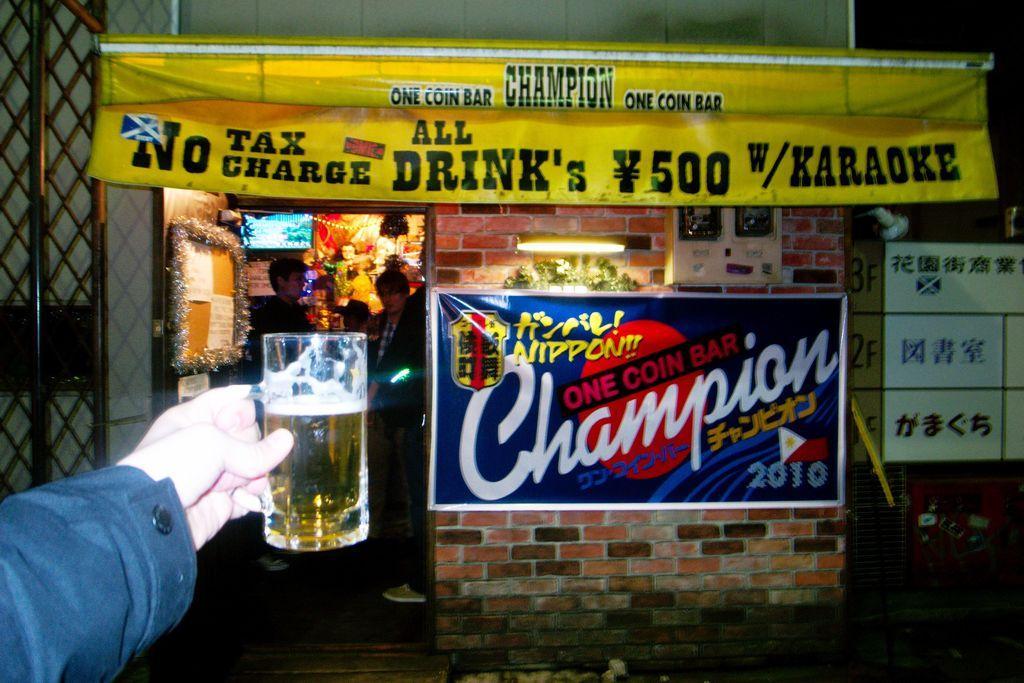Can you describe this image briefly? In this image I can see a person hand and holding glass. Back I can see store and few people. Banner are attached to the wall. They are in different color. We can see iron pole. 